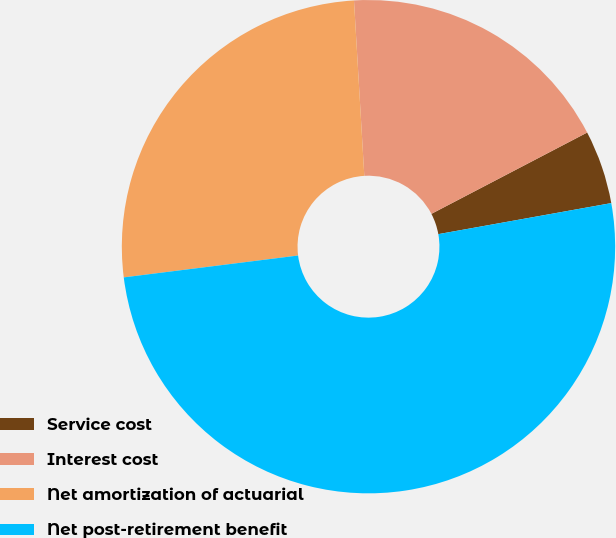<chart> <loc_0><loc_0><loc_500><loc_500><pie_chart><fcel>Service cost<fcel>Interest cost<fcel>Net amortization of actuarial<fcel>Net post-retirement benefit<nl><fcel>4.83%<fcel>18.28%<fcel>26.05%<fcel>50.84%<nl></chart> 